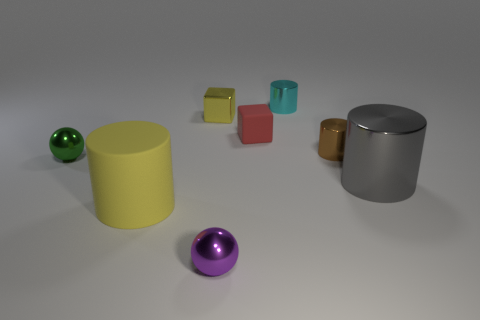Are there an equal number of yellow objects that are behind the tiny yellow shiny object and large gray rubber cubes?
Ensure brevity in your answer.  Yes. There is a gray cylinder; is it the same size as the cylinder to the left of the cyan metal object?
Offer a terse response. Yes. There is a object that is on the left side of the large matte thing; what shape is it?
Provide a short and direct response. Sphere. Are there any other things that have the same shape as the big gray shiny object?
Provide a succinct answer. Yes. Is there a tiny gray matte ball?
Keep it short and to the point. No. There is a yellow thing that is behind the gray thing; does it have the same size as the sphere that is right of the tiny green sphere?
Provide a short and direct response. Yes. There is a object that is in front of the gray object and behind the purple object; what is its material?
Your response must be concise. Rubber. What number of tiny balls are left of the large metal cylinder?
Offer a terse response. 2. Is there any other thing that has the same size as the yellow metal thing?
Give a very brief answer. Yes. There is a large object that is the same material as the small cyan thing; what is its color?
Offer a very short reply. Gray. 